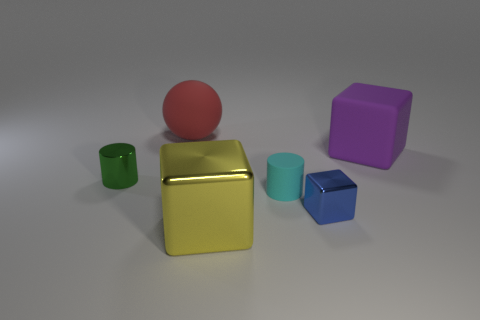Add 3 small green metallic objects. How many objects exist? 9 Subtract all spheres. How many objects are left? 5 Add 1 purple matte things. How many purple matte things exist? 2 Subtract 0 purple cylinders. How many objects are left? 6 Subtract all red objects. Subtract all purple blocks. How many objects are left? 4 Add 3 small blue shiny blocks. How many small blue shiny blocks are left? 4 